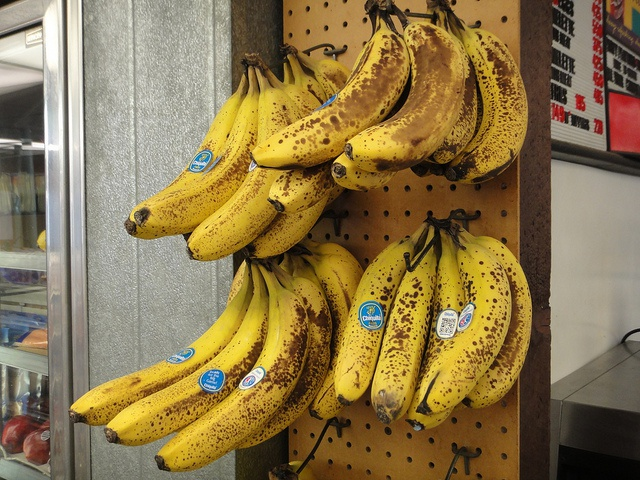Describe the objects in this image and their specific colors. I can see banana in black, gold, and olive tones, banana in black, orange, olive, and gold tones, banana in black, olive, and maroon tones, banana in black, gold, and olive tones, and banana in black, olive, orange, maroon, and tan tones in this image. 